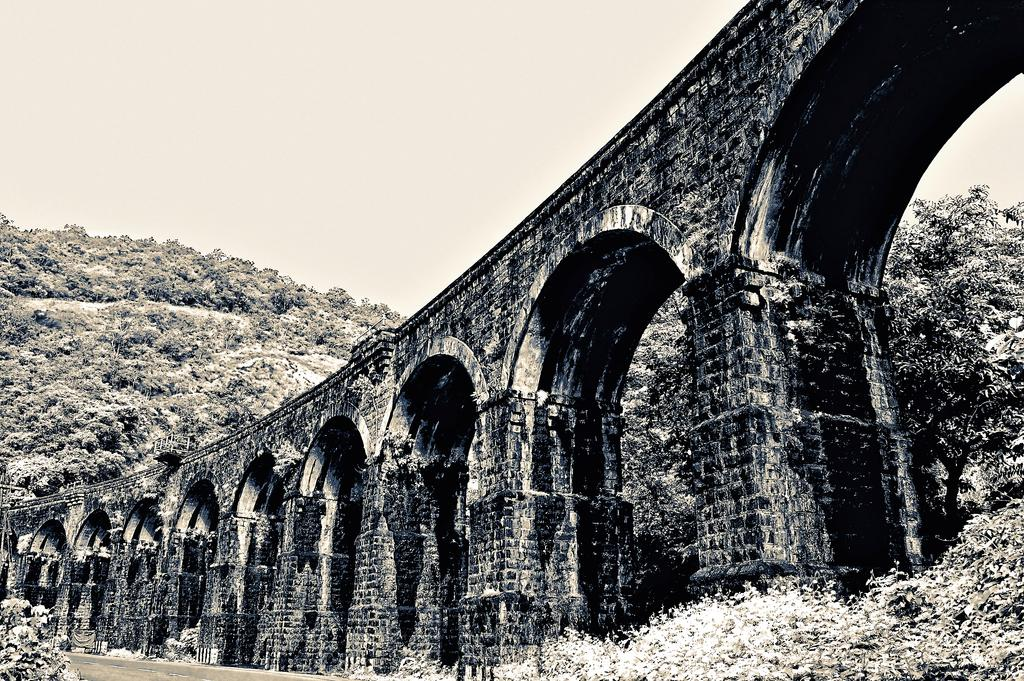What is the main structure in the middle of the image? There is a railway flyover in the middle of the image. What can be seen in the background of the image? There are trees in the background of the image. What is visible at the top of the image? The sky is visible at the top of the image. How many bags of cat food can be seen on the railway flyover? There are no bags of cat food present on the railway flyover in the image. What type of drink is being served at the top of the image? There is no drink visible at the top of the image, as it only shows the sky. 